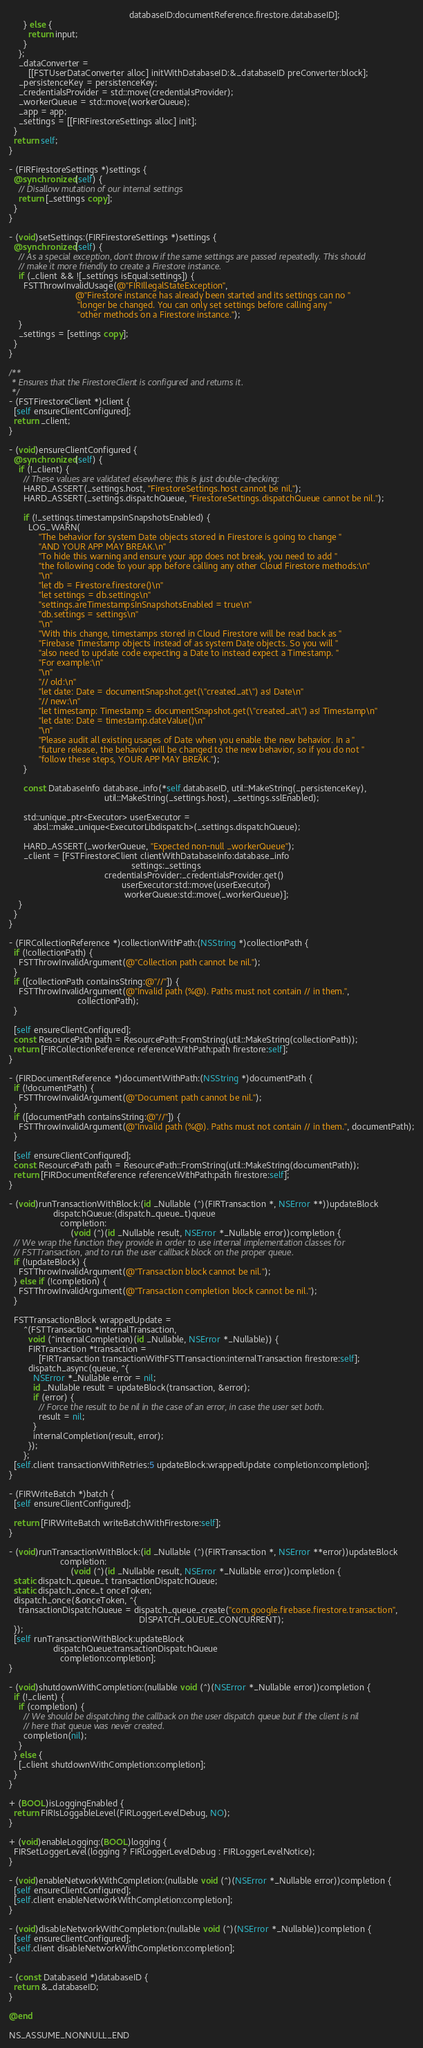Convert code to text. <code><loc_0><loc_0><loc_500><loc_500><_ObjectiveC_>                                                 databaseID:documentReference.firestore.databaseID];
      } else {
        return input;
      }
    };
    _dataConverter =
        [[FSTUserDataConverter alloc] initWithDatabaseID:&_databaseID preConverter:block];
    _persistenceKey = persistenceKey;
    _credentialsProvider = std::move(credentialsProvider);
    _workerQueue = std::move(workerQueue);
    _app = app;
    _settings = [[FIRFirestoreSettings alloc] init];
  }
  return self;
}

- (FIRFirestoreSettings *)settings {
  @synchronized(self) {
    // Disallow mutation of our internal settings
    return [_settings copy];
  }
}

- (void)setSettings:(FIRFirestoreSettings *)settings {
  @synchronized(self) {
    // As a special exception, don't throw if the same settings are passed repeatedly. This should
    // make it more friendly to create a Firestore instance.
    if (_client && ![_settings isEqual:settings]) {
      FSTThrowInvalidUsage(@"FIRIllegalStateException",
                           @"Firestore instance has already been started and its settings can no "
                            "longer be changed. You can only set settings before calling any "
                            "other methods on a Firestore instance.");
    }
    _settings = [settings copy];
  }
}

/**
 * Ensures that the FirestoreClient is configured and returns it.
 */
- (FSTFirestoreClient *)client {
  [self ensureClientConfigured];
  return _client;
}

- (void)ensureClientConfigured {
  @synchronized(self) {
    if (!_client) {
      // These values are validated elsewhere; this is just double-checking:
      HARD_ASSERT(_settings.host, "FirestoreSettings.host cannot be nil.");
      HARD_ASSERT(_settings.dispatchQueue, "FirestoreSettings.dispatchQueue cannot be nil.");

      if (!_settings.timestampsInSnapshotsEnabled) {
        LOG_WARN(
            "The behavior for system Date objects stored in Firestore is going to change "
            "AND YOUR APP MAY BREAK.\n"
            "To hide this warning and ensure your app does not break, you need to add "
            "the following code to your app before calling any other Cloud Firestore methods:\n"
            "\n"
            "let db = Firestore.firestore()\n"
            "let settings = db.settings\n"
            "settings.areTimestampsInSnapshotsEnabled = true\n"
            "db.settings = settings\n"
            "\n"
            "With this change, timestamps stored in Cloud Firestore will be read back as "
            "Firebase Timestamp objects instead of as system Date objects. So you will "
            "also need to update code expecting a Date to instead expect a Timestamp. "
            "For example:\n"
            "\n"
            "// old:\n"
            "let date: Date = documentSnapshot.get(\"created_at\") as! Date\n"
            "// new:\n"
            "let timestamp: Timestamp = documentSnapshot.get(\"created_at\") as! Timestamp\n"
            "let date: Date = timestamp.dateValue()\n"
            "\n"
            "Please audit all existing usages of Date when you enable the new behavior. In a "
            "future release, the behavior will be changed to the new behavior, so if you do not "
            "follow these steps, YOUR APP MAY BREAK.");
      }

      const DatabaseInfo database_info(*self.databaseID, util::MakeString(_persistenceKey),
                                       util::MakeString(_settings.host), _settings.sslEnabled);

      std::unique_ptr<Executor> userExecutor =
          absl::make_unique<ExecutorLibdispatch>(_settings.dispatchQueue);

      HARD_ASSERT(_workerQueue, "Expected non-null _workerQueue");
      _client = [FSTFirestoreClient clientWithDatabaseInfo:database_info
                                                  settings:_settings
                                       credentialsProvider:_credentialsProvider.get()
                                              userExecutor:std::move(userExecutor)
                                               workerQueue:std::move(_workerQueue)];
    }
  }
}

- (FIRCollectionReference *)collectionWithPath:(NSString *)collectionPath {
  if (!collectionPath) {
    FSTThrowInvalidArgument(@"Collection path cannot be nil.");
  }
  if ([collectionPath containsString:@"//"]) {
    FSTThrowInvalidArgument(@"Invalid path (%@). Paths must not contain // in them.",
                            collectionPath);
  }

  [self ensureClientConfigured];
  const ResourcePath path = ResourcePath::FromString(util::MakeString(collectionPath));
  return [FIRCollectionReference referenceWithPath:path firestore:self];
}

- (FIRDocumentReference *)documentWithPath:(NSString *)documentPath {
  if (!documentPath) {
    FSTThrowInvalidArgument(@"Document path cannot be nil.");
  }
  if ([documentPath containsString:@"//"]) {
    FSTThrowInvalidArgument(@"Invalid path (%@). Paths must not contain // in them.", documentPath);
  }

  [self ensureClientConfigured];
  const ResourcePath path = ResourcePath::FromString(util::MakeString(documentPath));
  return [FIRDocumentReference referenceWithPath:path firestore:self];
}

- (void)runTransactionWithBlock:(id _Nullable (^)(FIRTransaction *, NSError **))updateBlock
                  dispatchQueue:(dispatch_queue_t)queue
                     completion:
                         (void (^)(id _Nullable result, NSError *_Nullable error))completion {
  // We wrap the function they provide in order to use internal implementation classes for
  // FSTTransaction, and to run the user callback block on the proper queue.
  if (!updateBlock) {
    FSTThrowInvalidArgument(@"Transaction block cannot be nil.");
  } else if (!completion) {
    FSTThrowInvalidArgument(@"Transaction completion block cannot be nil.");
  }

  FSTTransactionBlock wrappedUpdate =
      ^(FSTTransaction *internalTransaction,
        void (^internalCompletion)(id _Nullable, NSError *_Nullable)) {
        FIRTransaction *transaction =
            [FIRTransaction transactionWithFSTTransaction:internalTransaction firestore:self];
        dispatch_async(queue, ^{
          NSError *_Nullable error = nil;
          id _Nullable result = updateBlock(transaction, &error);
          if (error) {
            // Force the result to be nil in the case of an error, in case the user set both.
            result = nil;
          }
          internalCompletion(result, error);
        });
      };
  [self.client transactionWithRetries:5 updateBlock:wrappedUpdate completion:completion];
}

- (FIRWriteBatch *)batch {
  [self ensureClientConfigured];

  return [FIRWriteBatch writeBatchWithFirestore:self];
}

- (void)runTransactionWithBlock:(id _Nullable (^)(FIRTransaction *, NSError **error))updateBlock
                     completion:
                         (void (^)(id _Nullable result, NSError *_Nullable error))completion {
  static dispatch_queue_t transactionDispatchQueue;
  static dispatch_once_t onceToken;
  dispatch_once(&onceToken, ^{
    transactionDispatchQueue = dispatch_queue_create("com.google.firebase.firestore.transaction",
                                                     DISPATCH_QUEUE_CONCURRENT);
  });
  [self runTransactionWithBlock:updateBlock
                  dispatchQueue:transactionDispatchQueue
                     completion:completion];
}

- (void)shutdownWithCompletion:(nullable void (^)(NSError *_Nullable error))completion {
  if (!_client) {
    if (completion) {
      // We should be dispatching the callback on the user dispatch queue but if the client is nil
      // here that queue was never created.
      completion(nil);
    }
  } else {
    [_client shutdownWithCompletion:completion];
  }
}

+ (BOOL)isLoggingEnabled {
  return FIRIsLoggableLevel(FIRLoggerLevelDebug, NO);
}

+ (void)enableLogging:(BOOL)logging {
  FIRSetLoggerLevel(logging ? FIRLoggerLevelDebug : FIRLoggerLevelNotice);
}

- (void)enableNetworkWithCompletion:(nullable void (^)(NSError *_Nullable error))completion {
  [self ensureClientConfigured];
  [self.client enableNetworkWithCompletion:completion];
}

- (void)disableNetworkWithCompletion:(nullable void (^)(NSError *_Nullable))completion {
  [self ensureClientConfigured];
  [self.client disableNetworkWithCompletion:completion];
}

- (const DatabaseId *)databaseID {
  return &_databaseID;
}

@end

NS_ASSUME_NONNULL_END
</code> 